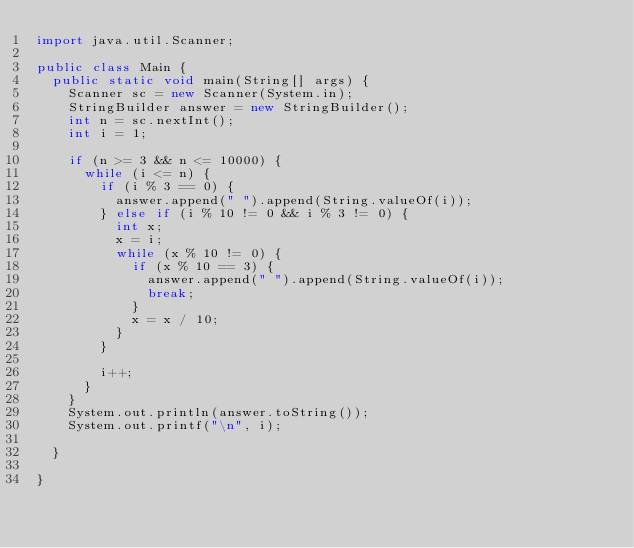<code> <loc_0><loc_0><loc_500><loc_500><_Java_>import java.util.Scanner;

public class Main {
	public static void main(String[] args) {
		Scanner sc = new Scanner(System.in);
		StringBuilder answer = new StringBuilder();
		int n = sc.nextInt();
		int i = 1;

		if (n >= 3 && n <= 10000) {
			while (i <= n) {
				if (i % 3 == 0) {
					answer.append(" ").append(String.valueOf(i));
				} else if (i % 10 != 0 && i % 3 != 0) {
					int x;
					x = i;
					while (x % 10 != 0) {
						if (x % 10 == 3) {
							answer.append(" ").append(String.valueOf(i));
							break;
						}
						x = x / 10;
					}
				}

				i++;
			}
		}
		System.out.println(answer.toString());
		System.out.printf("\n", i);

	}

}</code> 